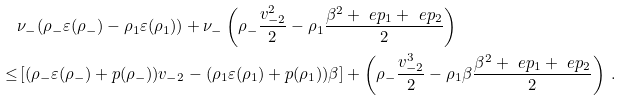Convert formula to latex. <formula><loc_0><loc_0><loc_500><loc_500>& \nu _ { - } ( \rho _ { - } \varepsilon ( \rho _ { - } ) - \rho _ { 1 } \varepsilon ( \rho _ { 1 } ) ) + \nu _ { - } \left ( \rho _ { - } \frac { v _ { - 2 } ^ { 2 } } { 2 } - \rho _ { 1 } \frac { \beta ^ { 2 } + \ e p _ { 1 } + \ e p _ { 2 } } { 2 } \right ) \\ \leq & \left [ ( \rho _ { - } \varepsilon ( \rho _ { - } ) + p ( \rho _ { - } ) ) v _ { - 2 } - ( \rho _ { 1 } \varepsilon ( \rho _ { 1 } ) + p ( \rho _ { 1 } ) ) \beta \right ] + \left ( \rho _ { - } \frac { v _ { - 2 } ^ { 3 } } { 2 } - \rho _ { 1 } \beta \frac { \beta ^ { 2 } + \ e p _ { 1 } + \ e p _ { 2 } } { 2 } \right ) \, .</formula> 